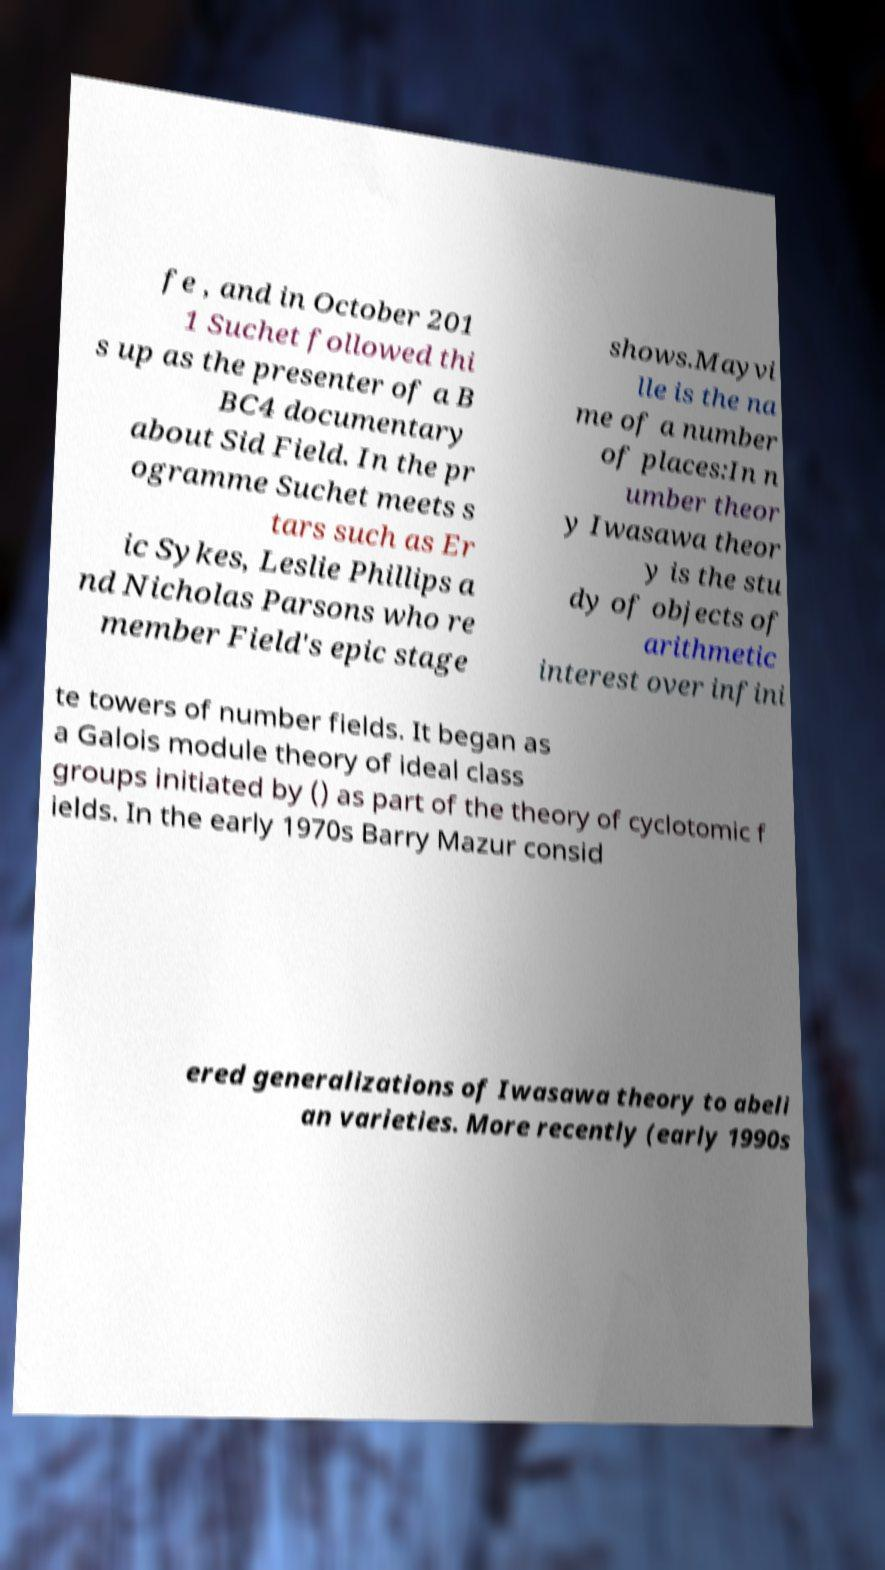Could you extract and type out the text from this image? fe , and in October 201 1 Suchet followed thi s up as the presenter of a B BC4 documentary about Sid Field. In the pr ogramme Suchet meets s tars such as Er ic Sykes, Leslie Phillips a nd Nicholas Parsons who re member Field's epic stage shows.Mayvi lle is the na me of a number of places:In n umber theor y Iwasawa theor y is the stu dy of objects of arithmetic interest over infini te towers of number fields. It began as a Galois module theory of ideal class groups initiated by () as part of the theory of cyclotomic f ields. In the early 1970s Barry Mazur consid ered generalizations of Iwasawa theory to abeli an varieties. More recently (early 1990s 